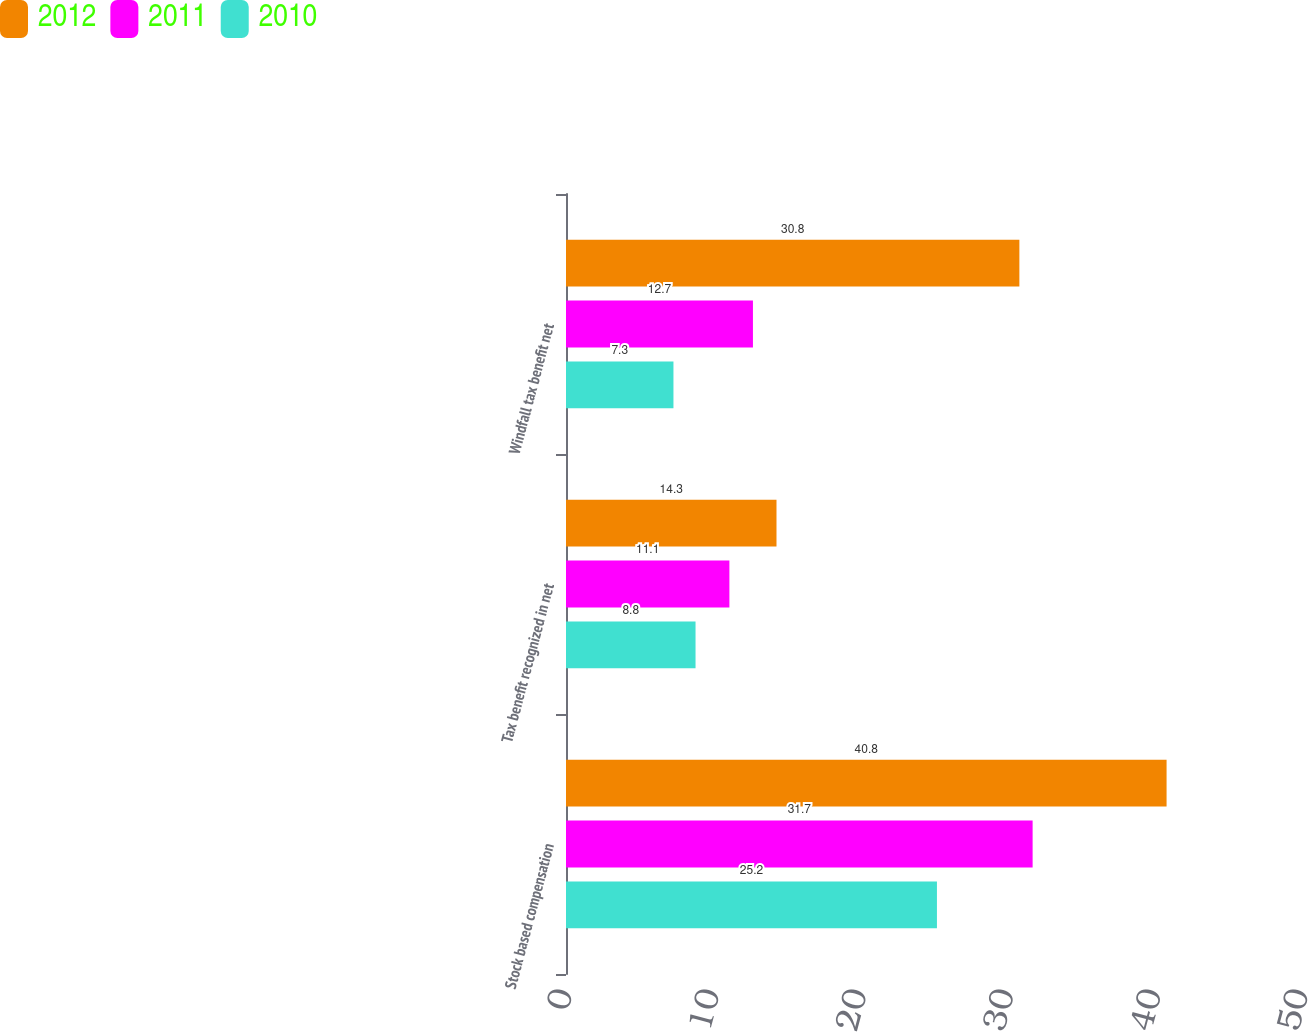<chart> <loc_0><loc_0><loc_500><loc_500><stacked_bar_chart><ecel><fcel>Stock based compensation<fcel>Tax benefit recognized in net<fcel>Windfall tax benefit net<nl><fcel>2012<fcel>40.8<fcel>14.3<fcel>30.8<nl><fcel>2011<fcel>31.7<fcel>11.1<fcel>12.7<nl><fcel>2010<fcel>25.2<fcel>8.8<fcel>7.3<nl></chart> 